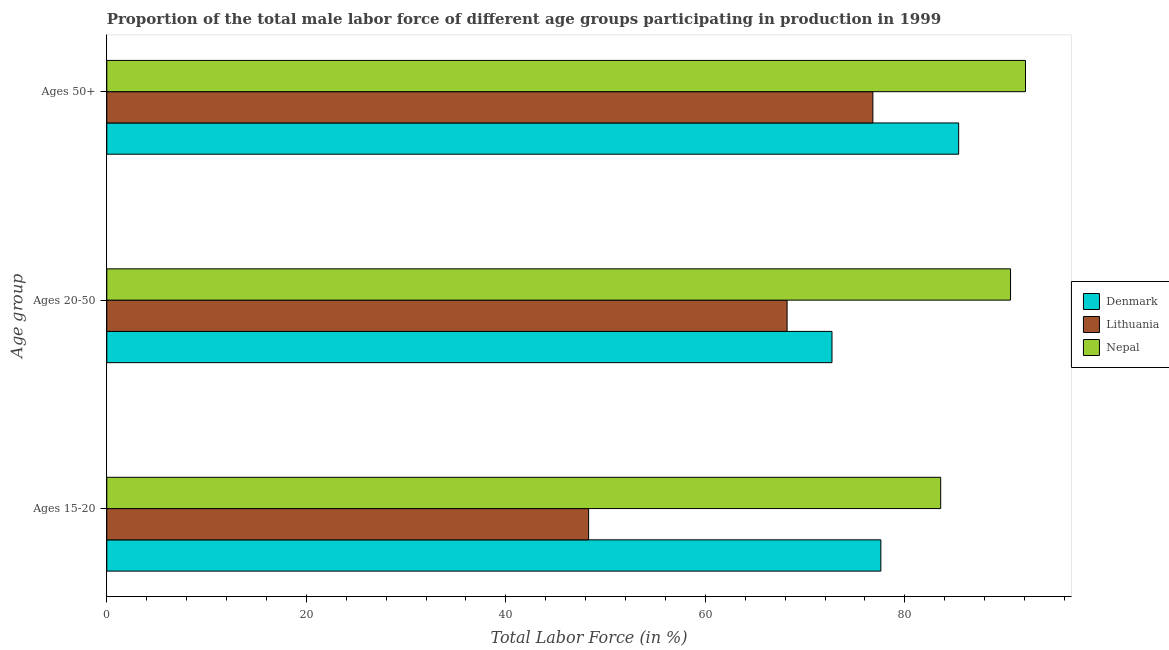How many different coloured bars are there?
Offer a terse response. 3. Are the number of bars on each tick of the Y-axis equal?
Keep it short and to the point. Yes. How many bars are there on the 3rd tick from the bottom?
Provide a succinct answer. 3. What is the label of the 2nd group of bars from the top?
Provide a short and direct response. Ages 20-50. What is the percentage of male labor force within the age group 15-20 in Denmark?
Provide a succinct answer. 77.6. Across all countries, what is the maximum percentage of male labor force above age 50?
Your response must be concise. 92.1. Across all countries, what is the minimum percentage of male labor force within the age group 15-20?
Make the answer very short. 48.3. In which country was the percentage of male labor force above age 50 maximum?
Your response must be concise. Nepal. In which country was the percentage of male labor force above age 50 minimum?
Keep it short and to the point. Lithuania. What is the total percentage of male labor force above age 50 in the graph?
Your response must be concise. 254.3. What is the difference between the percentage of male labor force within the age group 15-20 in Denmark and that in Nepal?
Give a very brief answer. -6. What is the difference between the percentage of male labor force above age 50 in Lithuania and the percentage of male labor force within the age group 20-50 in Denmark?
Offer a very short reply. 4.1. What is the average percentage of male labor force within the age group 15-20 per country?
Keep it short and to the point. 69.83. What is the difference between the percentage of male labor force within the age group 15-20 and percentage of male labor force within the age group 20-50 in Denmark?
Offer a very short reply. 4.9. What is the ratio of the percentage of male labor force above age 50 in Nepal to that in Denmark?
Ensure brevity in your answer.  1.08. Is the difference between the percentage of male labor force within the age group 20-50 in Lithuania and Denmark greater than the difference between the percentage of male labor force above age 50 in Lithuania and Denmark?
Ensure brevity in your answer.  Yes. What is the difference between the highest and the second highest percentage of male labor force within the age group 20-50?
Offer a very short reply. 17.9. What is the difference between the highest and the lowest percentage of male labor force above age 50?
Your response must be concise. 15.3. Is the sum of the percentage of male labor force within the age group 15-20 in Nepal and Lithuania greater than the maximum percentage of male labor force above age 50 across all countries?
Provide a short and direct response. Yes. What does the 2nd bar from the top in Ages 50+ represents?
Your answer should be very brief. Lithuania. What does the 3rd bar from the bottom in Ages 15-20 represents?
Offer a terse response. Nepal. Are all the bars in the graph horizontal?
Offer a terse response. Yes. How many countries are there in the graph?
Give a very brief answer. 3. What is the difference between two consecutive major ticks on the X-axis?
Provide a succinct answer. 20. Does the graph contain any zero values?
Provide a succinct answer. No. Does the graph contain grids?
Your response must be concise. No. Where does the legend appear in the graph?
Keep it short and to the point. Center right. How many legend labels are there?
Provide a succinct answer. 3. How are the legend labels stacked?
Make the answer very short. Vertical. What is the title of the graph?
Your response must be concise. Proportion of the total male labor force of different age groups participating in production in 1999. Does "Europe(all income levels)" appear as one of the legend labels in the graph?
Keep it short and to the point. No. What is the label or title of the Y-axis?
Make the answer very short. Age group. What is the Total Labor Force (in %) in Denmark in Ages 15-20?
Your answer should be compact. 77.6. What is the Total Labor Force (in %) of Lithuania in Ages 15-20?
Keep it short and to the point. 48.3. What is the Total Labor Force (in %) of Nepal in Ages 15-20?
Your answer should be very brief. 83.6. What is the Total Labor Force (in %) in Denmark in Ages 20-50?
Your response must be concise. 72.7. What is the Total Labor Force (in %) in Lithuania in Ages 20-50?
Give a very brief answer. 68.2. What is the Total Labor Force (in %) of Nepal in Ages 20-50?
Ensure brevity in your answer.  90.6. What is the Total Labor Force (in %) in Denmark in Ages 50+?
Give a very brief answer. 85.4. What is the Total Labor Force (in %) of Lithuania in Ages 50+?
Offer a terse response. 76.8. What is the Total Labor Force (in %) in Nepal in Ages 50+?
Provide a succinct answer. 92.1. Across all Age group, what is the maximum Total Labor Force (in %) in Denmark?
Offer a terse response. 85.4. Across all Age group, what is the maximum Total Labor Force (in %) of Lithuania?
Your answer should be very brief. 76.8. Across all Age group, what is the maximum Total Labor Force (in %) in Nepal?
Offer a very short reply. 92.1. Across all Age group, what is the minimum Total Labor Force (in %) in Denmark?
Offer a terse response. 72.7. Across all Age group, what is the minimum Total Labor Force (in %) in Lithuania?
Your answer should be very brief. 48.3. Across all Age group, what is the minimum Total Labor Force (in %) of Nepal?
Provide a short and direct response. 83.6. What is the total Total Labor Force (in %) of Denmark in the graph?
Offer a very short reply. 235.7. What is the total Total Labor Force (in %) of Lithuania in the graph?
Your answer should be compact. 193.3. What is the total Total Labor Force (in %) of Nepal in the graph?
Ensure brevity in your answer.  266.3. What is the difference between the Total Labor Force (in %) in Denmark in Ages 15-20 and that in Ages 20-50?
Give a very brief answer. 4.9. What is the difference between the Total Labor Force (in %) of Lithuania in Ages 15-20 and that in Ages 20-50?
Provide a succinct answer. -19.9. What is the difference between the Total Labor Force (in %) in Nepal in Ages 15-20 and that in Ages 20-50?
Keep it short and to the point. -7. What is the difference between the Total Labor Force (in %) of Denmark in Ages 15-20 and that in Ages 50+?
Provide a short and direct response. -7.8. What is the difference between the Total Labor Force (in %) in Lithuania in Ages 15-20 and that in Ages 50+?
Your answer should be compact. -28.5. What is the difference between the Total Labor Force (in %) of Nepal in Ages 15-20 and that in Ages 50+?
Ensure brevity in your answer.  -8.5. What is the difference between the Total Labor Force (in %) of Denmark in Ages 15-20 and the Total Labor Force (in %) of Nepal in Ages 20-50?
Provide a short and direct response. -13. What is the difference between the Total Labor Force (in %) in Lithuania in Ages 15-20 and the Total Labor Force (in %) in Nepal in Ages 20-50?
Offer a terse response. -42.3. What is the difference between the Total Labor Force (in %) of Denmark in Ages 15-20 and the Total Labor Force (in %) of Lithuania in Ages 50+?
Offer a very short reply. 0.8. What is the difference between the Total Labor Force (in %) in Lithuania in Ages 15-20 and the Total Labor Force (in %) in Nepal in Ages 50+?
Your answer should be compact. -43.8. What is the difference between the Total Labor Force (in %) in Denmark in Ages 20-50 and the Total Labor Force (in %) in Nepal in Ages 50+?
Your answer should be very brief. -19.4. What is the difference between the Total Labor Force (in %) of Lithuania in Ages 20-50 and the Total Labor Force (in %) of Nepal in Ages 50+?
Offer a very short reply. -23.9. What is the average Total Labor Force (in %) in Denmark per Age group?
Provide a short and direct response. 78.57. What is the average Total Labor Force (in %) of Lithuania per Age group?
Your answer should be very brief. 64.43. What is the average Total Labor Force (in %) in Nepal per Age group?
Offer a very short reply. 88.77. What is the difference between the Total Labor Force (in %) of Denmark and Total Labor Force (in %) of Lithuania in Ages 15-20?
Make the answer very short. 29.3. What is the difference between the Total Labor Force (in %) in Lithuania and Total Labor Force (in %) in Nepal in Ages 15-20?
Offer a very short reply. -35.3. What is the difference between the Total Labor Force (in %) of Denmark and Total Labor Force (in %) of Lithuania in Ages 20-50?
Offer a very short reply. 4.5. What is the difference between the Total Labor Force (in %) of Denmark and Total Labor Force (in %) of Nepal in Ages 20-50?
Ensure brevity in your answer.  -17.9. What is the difference between the Total Labor Force (in %) of Lithuania and Total Labor Force (in %) of Nepal in Ages 20-50?
Ensure brevity in your answer.  -22.4. What is the difference between the Total Labor Force (in %) in Denmark and Total Labor Force (in %) in Nepal in Ages 50+?
Your answer should be compact. -6.7. What is the difference between the Total Labor Force (in %) in Lithuania and Total Labor Force (in %) in Nepal in Ages 50+?
Your response must be concise. -15.3. What is the ratio of the Total Labor Force (in %) of Denmark in Ages 15-20 to that in Ages 20-50?
Provide a succinct answer. 1.07. What is the ratio of the Total Labor Force (in %) of Lithuania in Ages 15-20 to that in Ages 20-50?
Your response must be concise. 0.71. What is the ratio of the Total Labor Force (in %) in Nepal in Ages 15-20 to that in Ages 20-50?
Keep it short and to the point. 0.92. What is the ratio of the Total Labor Force (in %) in Denmark in Ages 15-20 to that in Ages 50+?
Provide a succinct answer. 0.91. What is the ratio of the Total Labor Force (in %) of Lithuania in Ages 15-20 to that in Ages 50+?
Ensure brevity in your answer.  0.63. What is the ratio of the Total Labor Force (in %) of Nepal in Ages 15-20 to that in Ages 50+?
Your response must be concise. 0.91. What is the ratio of the Total Labor Force (in %) of Denmark in Ages 20-50 to that in Ages 50+?
Your answer should be compact. 0.85. What is the ratio of the Total Labor Force (in %) of Lithuania in Ages 20-50 to that in Ages 50+?
Your answer should be compact. 0.89. What is the ratio of the Total Labor Force (in %) of Nepal in Ages 20-50 to that in Ages 50+?
Provide a succinct answer. 0.98. What is the difference between the highest and the second highest Total Labor Force (in %) in Lithuania?
Make the answer very short. 8.6. What is the difference between the highest and the lowest Total Labor Force (in %) in Denmark?
Give a very brief answer. 12.7. What is the difference between the highest and the lowest Total Labor Force (in %) in Lithuania?
Provide a succinct answer. 28.5. 